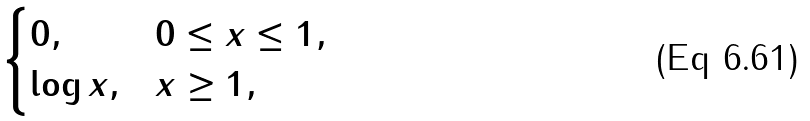Convert formula to latex. <formula><loc_0><loc_0><loc_500><loc_500>\begin{cases} 0 , & 0 \leq x \leq 1 , \\ \log { x } , & x \geq 1 , \end{cases}</formula> 